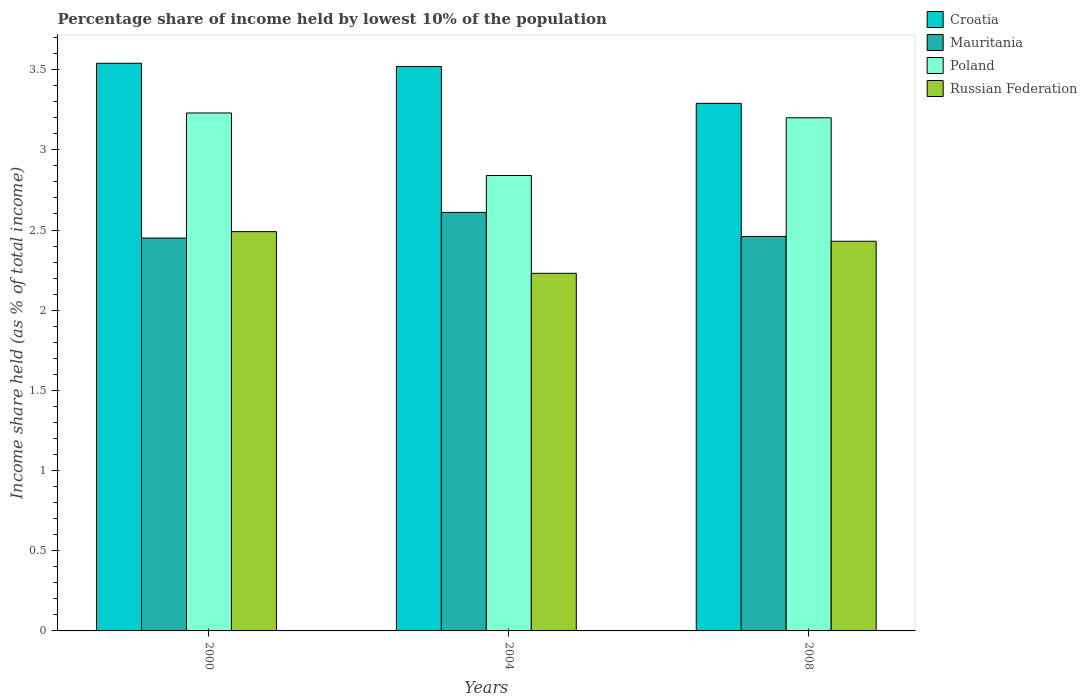How many different coloured bars are there?
Provide a short and direct response. 4. Are the number of bars per tick equal to the number of legend labels?
Provide a short and direct response. Yes. Are the number of bars on each tick of the X-axis equal?
Your answer should be very brief. Yes. How many bars are there on the 2nd tick from the left?
Provide a short and direct response. 4. In how many cases, is the number of bars for a given year not equal to the number of legend labels?
Give a very brief answer. 0. What is the percentage share of income held by lowest 10% of the population in Croatia in 2008?
Your response must be concise. 3.29. Across all years, what is the maximum percentage share of income held by lowest 10% of the population in Russian Federation?
Give a very brief answer. 2.49. Across all years, what is the minimum percentage share of income held by lowest 10% of the population in Croatia?
Provide a short and direct response. 3.29. In which year was the percentage share of income held by lowest 10% of the population in Russian Federation minimum?
Provide a succinct answer. 2004. What is the total percentage share of income held by lowest 10% of the population in Mauritania in the graph?
Ensure brevity in your answer.  7.52. What is the difference between the percentage share of income held by lowest 10% of the population in Russian Federation in 2004 and that in 2008?
Provide a short and direct response. -0.2. What is the average percentage share of income held by lowest 10% of the population in Mauritania per year?
Ensure brevity in your answer.  2.51. In the year 2000, what is the difference between the percentage share of income held by lowest 10% of the population in Croatia and percentage share of income held by lowest 10% of the population in Poland?
Your answer should be very brief. 0.31. What is the ratio of the percentage share of income held by lowest 10% of the population in Mauritania in 2000 to that in 2004?
Your response must be concise. 0.94. Is the difference between the percentage share of income held by lowest 10% of the population in Croatia in 2000 and 2004 greater than the difference between the percentage share of income held by lowest 10% of the population in Poland in 2000 and 2004?
Keep it short and to the point. No. What is the difference between the highest and the second highest percentage share of income held by lowest 10% of the population in Poland?
Your answer should be very brief. 0.03. What is the difference between the highest and the lowest percentage share of income held by lowest 10% of the population in Russian Federation?
Give a very brief answer. 0.26. Is the sum of the percentage share of income held by lowest 10% of the population in Mauritania in 2000 and 2008 greater than the maximum percentage share of income held by lowest 10% of the population in Poland across all years?
Ensure brevity in your answer.  Yes. Is it the case that in every year, the sum of the percentage share of income held by lowest 10% of the population in Russian Federation and percentage share of income held by lowest 10% of the population in Mauritania is greater than the sum of percentage share of income held by lowest 10% of the population in Poland and percentage share of income held by lowest 10% of the population in Croatia?
Your answer should be very brief. No. What does the 2nd bar from the left in 2004 represents?
Keep it short and to the point. Mauritania. What does the 1st bar from the right in 2000 represents?
Keep it short and to the point. Russian Federation. How many bars are there?
Your answer should be very brief. 12. Are the values on the major ticks of Y-axis written in scientific E-notation?
Your response must be concise. No. Does the graph contain grids?
Provide a succinct answer. No. Where does the legend appear in the graph?
Your answer should be very brief. Top right. How are the legend labels stacked?
Offer a very short reply. Vertical. What is the title of the graph?
Your answer should be very brief. Percentage share of income held by lowest 10% of the population. Does "Costa Rica" appear as one of the legend labels in the graph?
Offer a very short reply. No. What is the label or title of the X-axis?
Offer a very short reply. Years. What is the label or title of the Y-axis?
Make the answer very short. Income share held (as % of total income). What is the Income share held (as % of total income) in Croatia in 2000?
Keep it short and to the point. 3.54. What is the Income share held (as % of total income) in Mauritania in 2000?
Provide a succinct answer. 2.45. What is the Income share held (as % of total income) of Poland in 2000?
Offer a terse response. 3.23. What is the Income share held (as % of total income) in Russian Federation in 2000?
Make the answer very short. 2.49. What is the Income share held (as % of total income) of Croatia in 2004?
Make the answer very short. 3.52. What is the Income share held (as % of total income) in Mauritania in 2004?
Offer a very short reply. 2.61. What is the Income share held (as % of total income) in Poland in 2004?
Provide a succinct answer. 2.84. What is the Income share held (as % of total income) in Russian Federation in 2004?
Give a very brief answer. 2.23. What is the Income share held (as % of total income) of Croatia in 2008?
Offer a terse response. 3.29. What is the Income share held (as % of total income) in Mauritania in 2008?
Offer a very short reply. 2.46. What is the Income share held (as % of total income) in Poland in 2008?
Offer a terse response. 3.2. What is the Income share held (as % of total income) of Russian Federation in 2008?
Offer a terse response. 2.43. Across all years, what is the maximum Income share held (as % of total income) in Croatia?
Offer a very short reply. 3.54. Across all years, what is the maximum Income share held (as % of total income) in Mauritania?
Provide a succinct answer. 2.61. Across all years, what is the maximum Income share held (as % of total income) in Poland?
Your response must be concise. 3.23. Across all years, what is the maximum Income share held (as % of total income) of Russian Federation?
Give a very brief answer. 2.49. Across all years, what is the minimum Income share held (as % of total income) in Croatia?
Provide a short and direct response. 3.29. Across all years, what is the minimum Income share held (as % of total income) in Mauritania?
Offer a very short reply. 2.45. Across all years, what is the minimum Income share held (as % of total income) of Poland?
Ensure brevity in your answer.  2.84. Across all years, what is the minimum Income share held (as % of total income) in Russian Federation?
Keep it short and to the point. 2.23. What is the total Income share held (as % of total income) of Croatia in the graph?
Offer a terse response. 10.35. What is the total Income share held (as % of total income) of Mauritania in the graph?
Keep it short and to the point. 7.52. What is the total Income share held (as % of total income) of Poland in the graph?
Keep it short and to the point. 9.27. What is the total Income share held (as % of total income) of Russian Federation in the graph?
Provide a succinct answer. 7.15. What is the difference between the Income share held (as % of total income) of Croatia in 2000 and that in 2004?
Make the answer very short. 0.02. What is the difference between the Income share held (as % of total income) in Mauritania in 2000 and that in 2004?
Make the answer very short. -0.16. What is the difference between the Income share held (as % of total income) of Poland in 2000 and that in 2004?
Your answer should be compact. 0.39. What is the difference between the Income share held (as % of total income) in Russian Federation in 2000 and that in 2004?
Give a very brief answer. 0.26. What is the difference between the Income share held (as % of total income) of Mauritania in 2000 and that in 2008?
Give a very brief answer. -0.01. What is the difference between the Income share held (as % of total income) of Croatia in 2004 and that in 2008?
Your response must be concise. 0.23. What is the difference between the Income share held (as % of total income) in Mauritania in 2004 and that in 2008?
Your answer should be very brief. 0.15. What is the difference between the Income share held (as % of total income) of Poland in 2004 and that in 2008?
Provide a short and direct response. -0.36. What is the difference between the Income share held (as % of total income) of Croatia in 2000 and the Income share held (as % of total income) of Mauritania in 2004?
Give a very brief answer. 0.93. What is the difference between the Income share held (as % of total income) in Croatia in 2000 and the Income share held (as % of total income) in Russian Federation in 2004?
Make the answer very short. 1.31. What is the difference between the Income share held (as % of total income) in Mauritania in 2000 and the Income share held (as % of total income) in Poland in 2004?
Offer a terse response. -0.39. What is the difference between the Income share held (as % of total income) in Mauritania in 2000 and the Income share held (as % of total income) in Russian Federation in 2004?
Offer a terse response. 0.22. What is the difference between the Income share held (as % of total income) in Poland in 2000 and the Income share held (as % of total income) in Russian Federation in 2004?
Give a very brief answer. 1. What is the difference between the Income share held (as % of total income) of Croatia in 2000 and the Income share held (as % of total income) of Mauritania in 2008?
Your response must be concise. 1.08. What is the difference between the Income share held (as % of total income) of Croatia in 2000 and the Income share held (as % of total income) of Poland in 2008?
Provide a succinct answer. 0.34. What is the difference between the Income share held (as % of total income) in Croatia in 2000 and the Income share held (as % of total income) in Russian Federation in 2008?
Provide a succinct answer. 1.11. What is the difference between the Income share held (as % of total income) of Mauritania in 2000 and the Income share held (as % of total income) of Poland in 2008?
Keep it short and to the point. -0.75. What is the difference between the Income share held (as % of total income) of Mauritania in 2000 and the Income share held (as % of total income) of Russian Federation in 2008?
Make the answer very short. 0.02. What is the difference between the Income share held (as % of total income) of Poland in 2000 and the Income share held (as % of total income) of Russian Federation in 2008?
Your response must be concise. 0.8. What is the difference between the Income share held (as % of total income) of Croatia in 2004 and the Income share held (as % of total income) of Mauritania in 2008?
Your answer should be very brief. 1.06. What is the difference between the Income share held (as % of total income) of Croatia in 2004 and the Income share held (as % of total income) of Poland in 2008?
Your answer should be compact. 0.32. What is the difference between the Income share held (as % of total income) of Croatia in 2004 and the Income share held (as % of total income) of Russian Federation in 2008?
Your answer should be very brief. 1.09. What is the difference between the Income share held (as % of total income) in Mauritania in 2004 and the Income share held (as % of total income) in Poland in 2008?
Provide a succinct answer. -0.59. What is the difference between the Income share held (as % of total income) of Mauritania in 2004 and the Income share held (as % of total income) of Russian Federation in 2008?
Keep it short and to the point. 0.18. What is the difference between the Income share held (as % of total income) in Poland in 2004 and the Income share held (as % of total income) in Russian Federation in 2008?
Your response must be concise. 0.41. What is the average Income share held (as % of total income) in Croatia per year?
Provide a succinct answer. 3.45. What is the average Income share held (as % of total income) of Mauritania per year?
Your answer should be compact. 2.51. What is the average Income share held (as % of total income) of Poland per year?
Provide a succinct answer. 3.09. What is the average Income share held (as % of total income) of Russian Federation per year?
Provide a succinct answer. 2.38. In the year 2000, what is the difference between the Income share held (as % of total income) of Croatia and Income share held (as % of total income) of Mauritania?
Give a very brief answer. 1.09. In the year 2000, what is the difference between the Income share held (as % of total income) of Croatia and Income share held (as % of total income) of Poland?
Ensure brevity in your answer.  0.31. In the year 2000, what is the difference between the Income share held (as % of total income) of Croatia and Income share held (as % of total income) of Russian Federation?
Offer a very short reply. 1.05. In the year 2000, what is the difference between the Income share held (as % of total income) in Mauritania and Income share held (as % of total income) in Poland?
Provide a short and direct response. -0.78. In the year 2000, what is the difference between the Income share held (as % of total income) in Mauritania and Income share held (as % of total income) in Russian Federation?
Keep it short and to the point. -0.04. In the year 2000, what is the difference between the Income share held (as % of total income) of Poland and Income share held (as % of total income) of Russian Federation?
Make the answer very short. 0.74. In the year 2004, what is the difference between the Income share held (as % of total income) of Croatia and Income share held (as % of total income) of Mauritania?
Make the answer very short. 0.91. In the year 2004, what is the difference between the Income share held (as % of total income) of Croatia and Income share held (as % of total income) of Poland?
Give a very brief answer. 0.68. In the year 2004, what is the difference between the Income share held (as % of total income) of Croatia and Income share held (as % of total income) of Russian Federation?
Offer a very short reply. 1.29. In the year 2004, what is the difference between the Income share held (as % of total income) in Mauritania and Income share held (as % of total income) in Poland?
Provide a short and direct response. -0.23. In the year 2004, what is the difference between the Income share held (as % of total income) in Mauritania and Income share held (as % of total income) in Russian Federation?
Provide a short and direct response. 0.38. In the year 2004, what is the difference between the Income share held (as % of total income) of Poland and Income share held (as % of total income) of Russian Federation?
Make the answer very short. 0.61. In the year 2008, what is the difference between the Income share held (as % of total income) in Croatia and Income share held (as % of total income) in Mauritania?
Offer a terse response. 0.83. In the year 2008, what is the difference between the Income share held (as % of total income) of Croatia and Income share held (as % of total income) of Poland?
Provide a succinct answer. 0.09. In the year 2008, what is the difference between the Income share held (as % of total income) of Croatia and Income share held (as % of total income) of Russian Federation?
Keep it short and to the point. 0.86. In the year 2008, what is the difference between the Income share held (as % of total income) of Mauritania and Income share held (as % of total income) of Poland?
Keep it short and to the point. -0.74. In the year 2008, what is the difference between the Income share held (as % of total income) of Mauritania and Income share held (as % of total income) of Russian Federation?
Provide a short and direct response. 0.03. In the year 2008, what is the difference between the Income share held (as % of total income) of Poland and Income share held (as % of total income) of Russian Federation?
Your response must be concise. 0.77. What is the ratio of the Income share held (as % of total income) in Croatia in 2000 to that in 2004?
Provide a short and direct response. 1.01. What is the ratio of the Income share held (as % of total income) in Mauritania in 2000 to that in 2004?
Your answer should be compact. 0.94. What is the ratio of the Income share held (as % of total income) of Poland in 2000 to that in 2004?
Offer a terse response. 1.14. What is the ratio of the Income share held (as % of total income) of Russian Federation in 2000 to that in 2004?
Offer a terse response. 1.12. What is the ratio of the Income share held (as % of total income) in Croatia in 2000 to that in 2008?
Your response must be concise. 1.08. What is the ratio of the Income share held (as % of total income) in Poland in 2000 to that in 2008?
Provide a succinct answer. 1.01. What is the ratio of the Income share held (as % of total income) of Russian Federation in 2000 to that in 2008?
Your response must be concise. 1.02. What is the ratio of the Income share held (as % of total income) of Croatia in 2004 to that in 2008?
Keep it short and to the point. 1.07. What is the ratio of the Income share held (as % of total income) of Mauritania in 2004 to that in 2008?
Offer a very short reply. 1.06. What is the ratio of the Income share held (as % of total income) of Poland in 2004 to that in 2008?
Offer a terse response. 0.89. What is the ratio of the Income share held (as % of total income) in Russian Federation in 2004 to that in 2008?
Your answer should be compact. 0.92. What is the difference between the highest and the second highest Income share held (as % of total income) of Russian Federation?
Your response must be concise. 0.06. What is the difference between the highest and the lowest Income share held (as % of total income) in Mauritania?
Offer a very short reply. 0.16. What is the difference between the highest and the lowest Income share held (as % of total income) in Poland?
Your answer should be compact. 0.39. What is the difference between the highest and the lowest Income share held (as % of total income) in Russian Federation?
Your response must be concise. 0.26. 